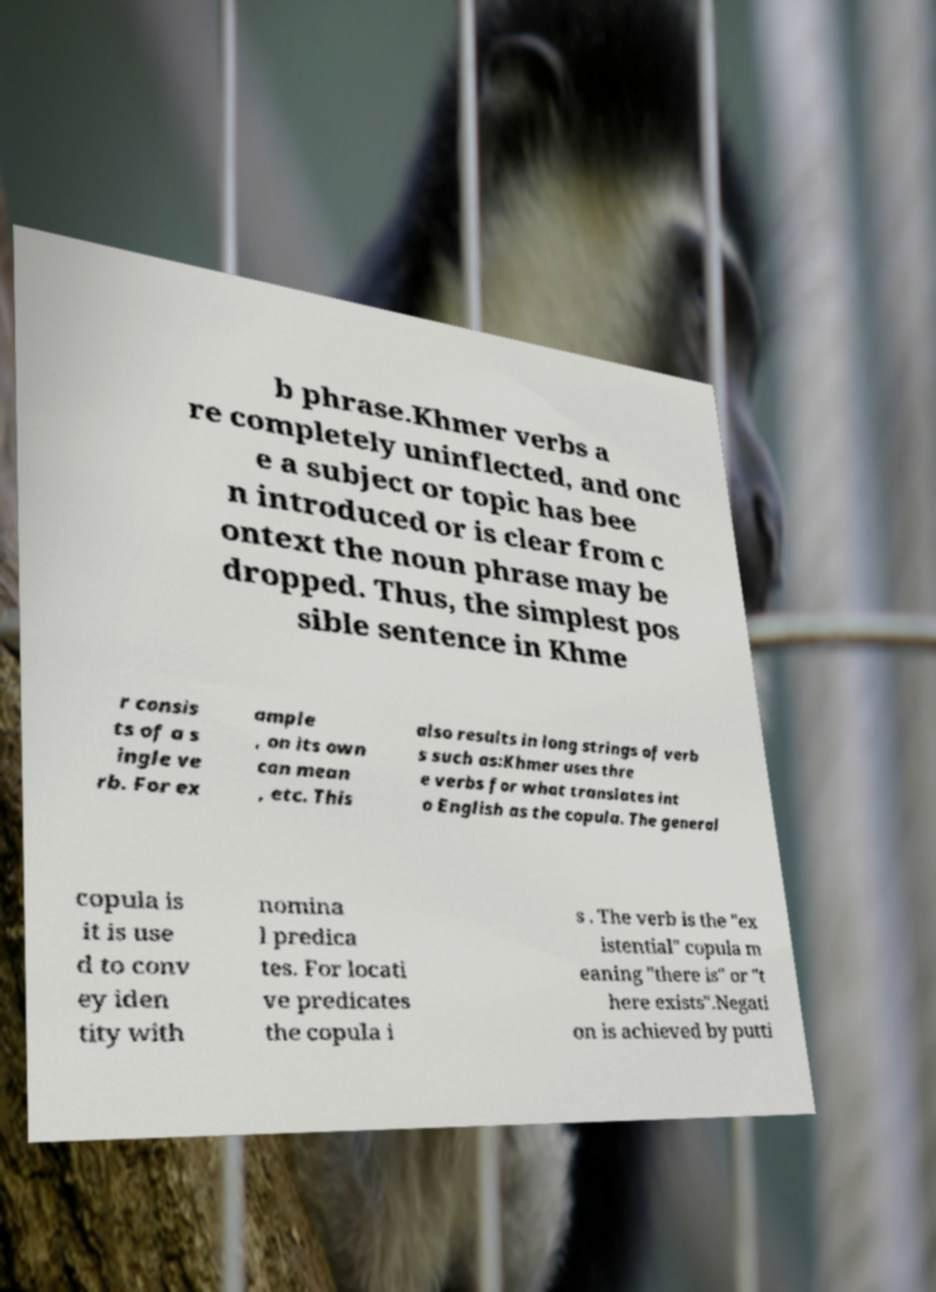Could you extract and type out the text from this image? b phrase.Khmer verbs a re completely uninflected, and onc e a subject or topic has bee n introduced or is clear from c ontext the noun phrase may be dropped. Thus, the simplest pos sible sentence in Khme r consis ts of a s ingle ve rb. For ex ample , on its own can mean , etc. This also results in long strings of verb s such as:Khmer uses thre e verbs for what translates int o English as the copula. The general copula is it is use d to conv ey iden tity with nomina l predica tes. For locati ve predicates the copula i s . The verb is the "ex istential" copula m eaning "there is" or "t here exists".Negati on is achieved by putti 